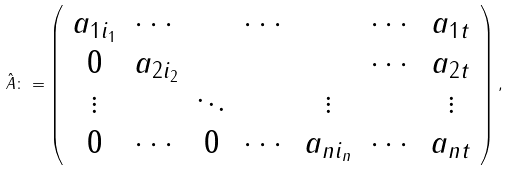Convert formula to latex. <formula><loc_0><loc_0><loc_500><loc_500>\hat { A } \colon = \left ( \begin{array} { c c c c c c c } a _ { 1 i _ { 1 } } & \cdots & & \cdots & & \cdots & a _ { 1 t } \\ 0 & a _ { 2 i _ { 2 } } & & & & \cdots & a _ { 2 t } \\ \vdots & & \ddots & & \vdots & & \vdots \\ 0 & \cdots & 0 & \cdots & a _ { n i _ { n } } & \cdots & a _ { n t } \end{array} \right ) ,</formula> 